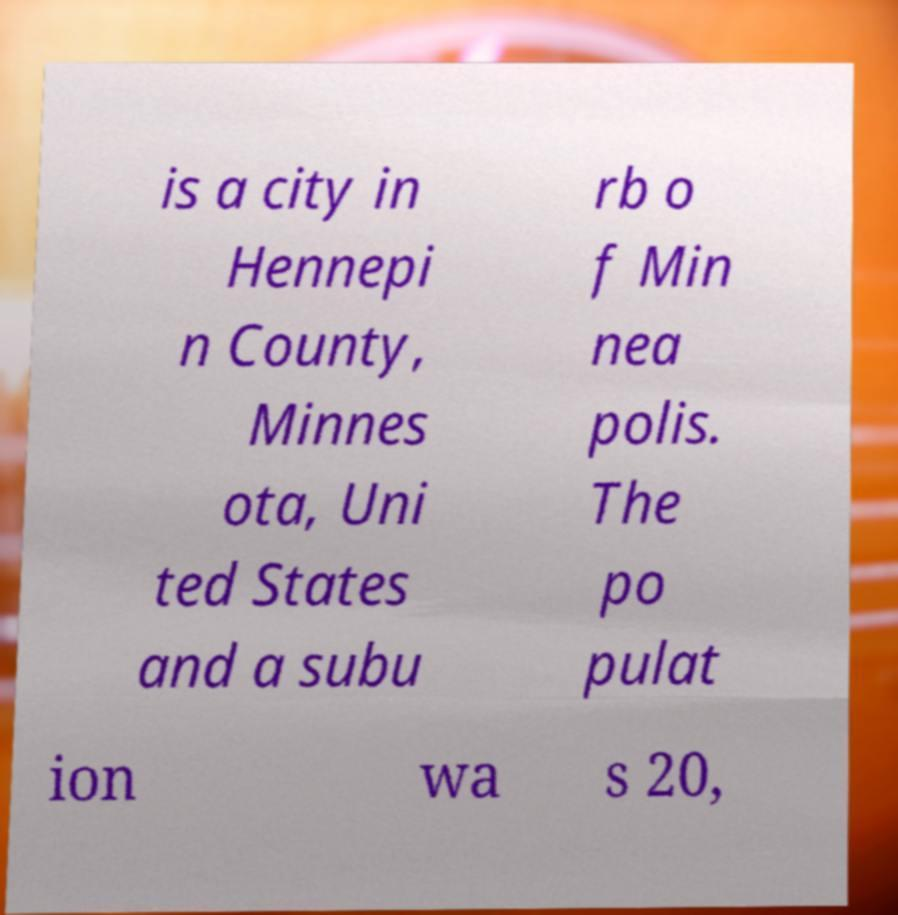Can you read and provide the text displayed in the image?This photo seems to have some interesting text. Can you extract and type it out for me? is a city in Hennepi n County, Minnes ota, Uni ted States and a subu rb o f Min nea polis. The po pulat ion wa s 20, 